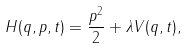<formula> <loc_0><loc_0><loc_500><loc_500>H ( q , p , t ) = \frac { p ^ { 2 } } { 2 } + \lambda V ( q , t ) ,</formula> 